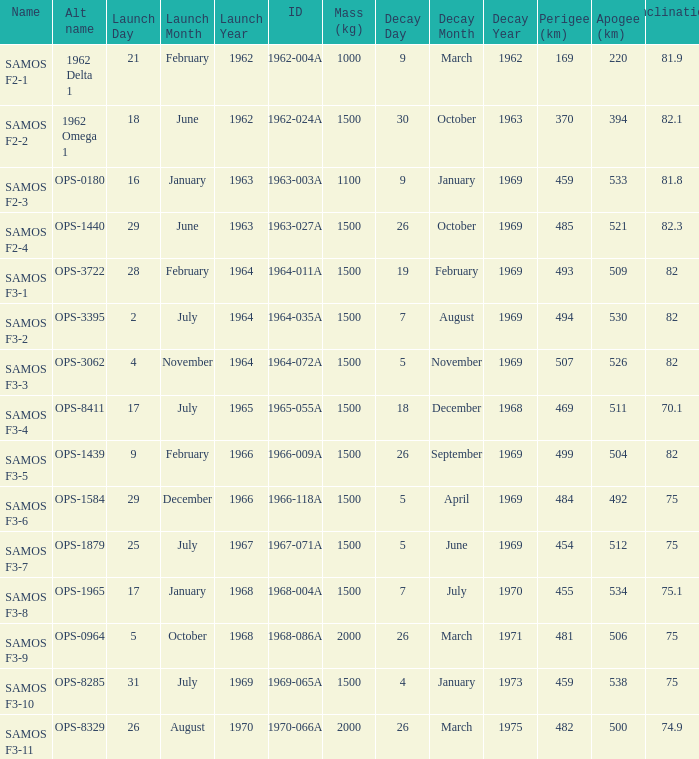What is the inclination when the alt name is OPS-1584? 75.0. 